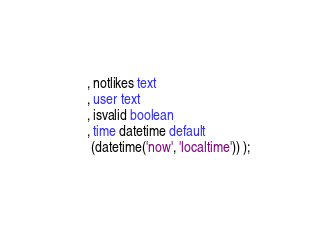<code> <loc_0><loc_0><loc_500><loc_500><_SQL_>   , notlikes text
   , user text
   , isvalid boolean
   , time datetime default
    (datetime('now', 'localtime')) );
</code> 